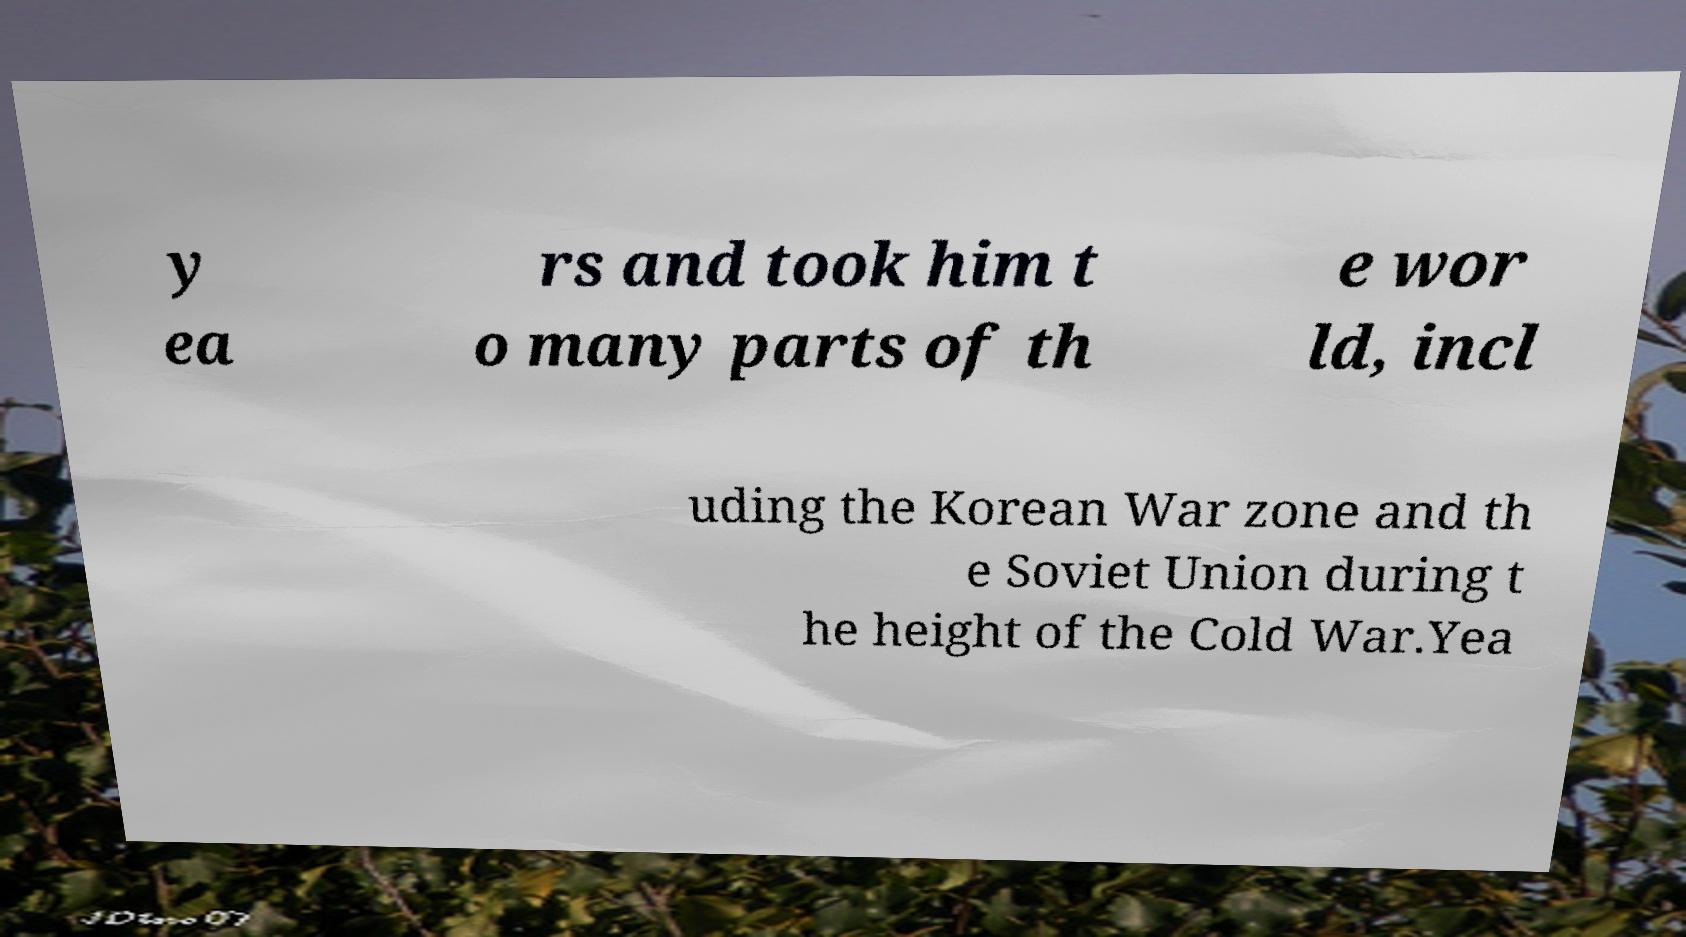Please read and relay the text visible in this image. What does it say? y ea rs and took him t o many parts of th e wor ld, incl uding the Korean War zone and th e Soviet Union during t he height of the Cold War.Yea 